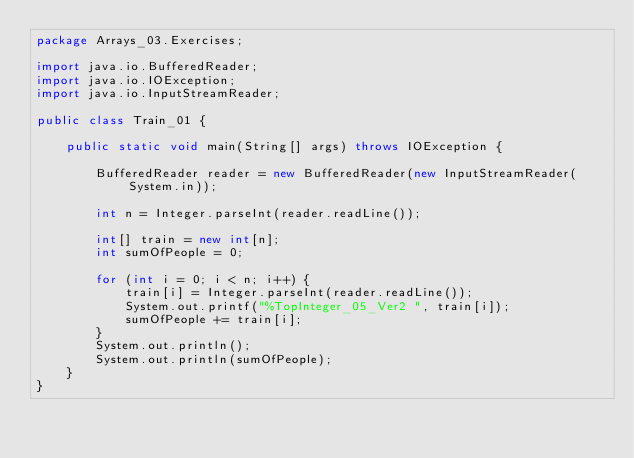Convert code to text. <code><loc_0><loc_0><loc_500><loc_500><_Java_>package Arrays_03.Exercises;

import java.io.BufferedReader;
import java.io.IOException;
import java.io.InputStreamReader;

public class Train_01 {

    public static void main(String[] args) throws IOException {

        BufferedReader reader = new BufferedReader(new InputStreamReader(System.in));

        int n = Integer.parseInt(reader.readLine());

        int[] train = new int[n];
        int sumOfPeople = 0;

        for (int i = 0; i < n; i++) {
            train[i] = Integer.parseInt(reader.readLine());
            System.out.printf("%TopInteger_05_Ver2 ", train[i]);
            sumOfPeople += train[i];
        }
        System.out.println();
        System.out.println(sumOfPeople);
    }
}
</code> 